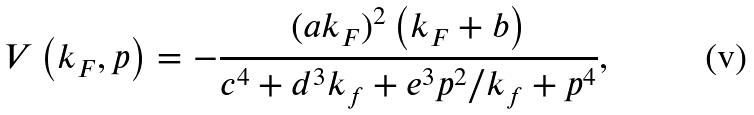<formula> <loc_0><loc_0><loc_500><loc_500>V \left ( { k _ { F } , p } \right ) = - \frac { ( a k _ { F } ) ^ { 2 } \left ( k _ { F } + b \right ) } { { c ^ { 4 } + d ^ { 3 } k _ { f } + e ^ { 3 } p ^ { 2 } / k _ { f } + { p } ^ { 4 } } } ,</formula> 